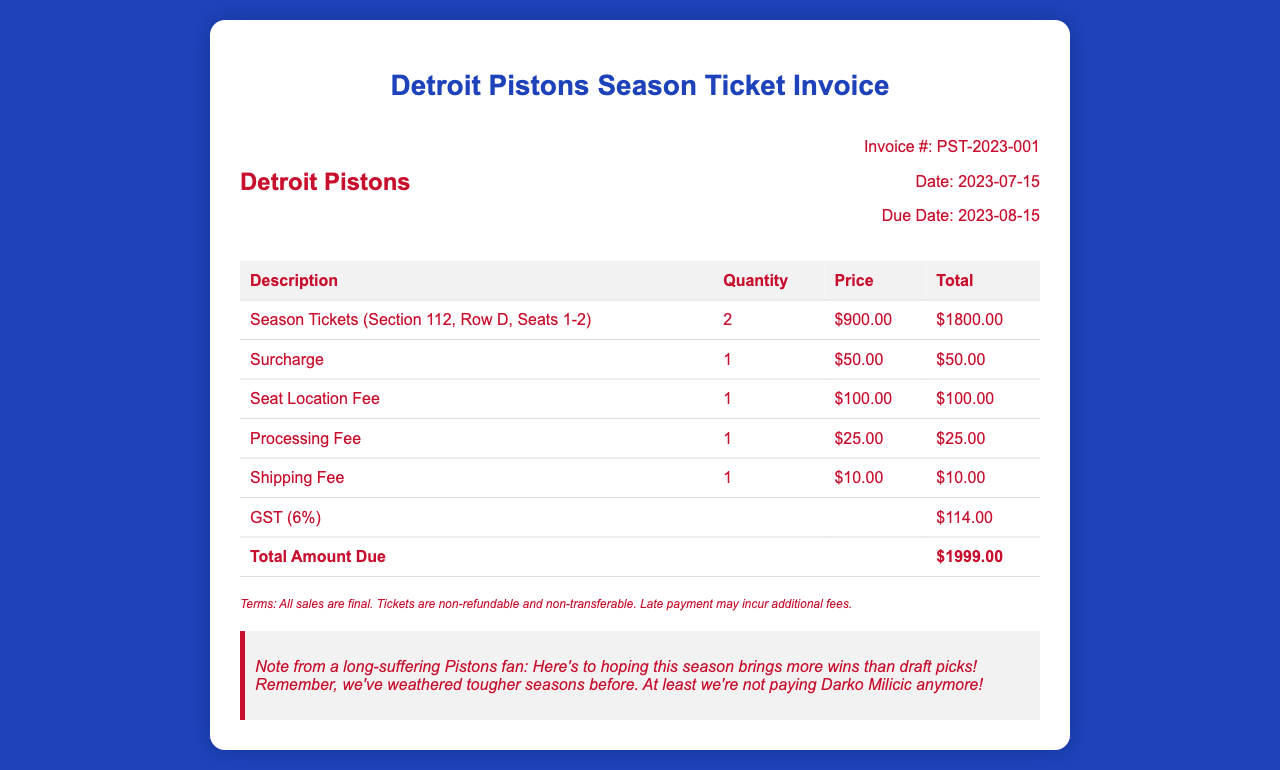What is the invoice number? The invoice number is stated clearly in the document, labeled as "Invoice #".
Answer: PST-2023-001 What is the total amount due? The document lists the total amount due at the bottom of the invoice table.
Answer: $1999.00 What is the date of the invoice? The document specifies the date the invoice was issued, labeled as "Date".
Answer: 2023-07-15 How many season tickets are purchased? The quantity of season tickets purchased is detailed in the table under "Quantity".
Answer: 2 What is the surcharge fee? The surcharge fee appears in the breakdown of additional charges in the invoice.
Answer: $50.00 What percentage is the GST? The GST is listed in the table, indicating its percentage clearly.
Answer: 6% What is the shipping fee? The document specifies the cost for shipping under additional charges.
Answer: $10.00 What does the fan note express? The fan note conveys a sentiment about the Pistons' performance and past experiences.
Answer: Hope for more wins What is the due date for the invoice? The document indicates a specific due date for payment, labeled as "Due Date".
Answer: 2023-08-15 